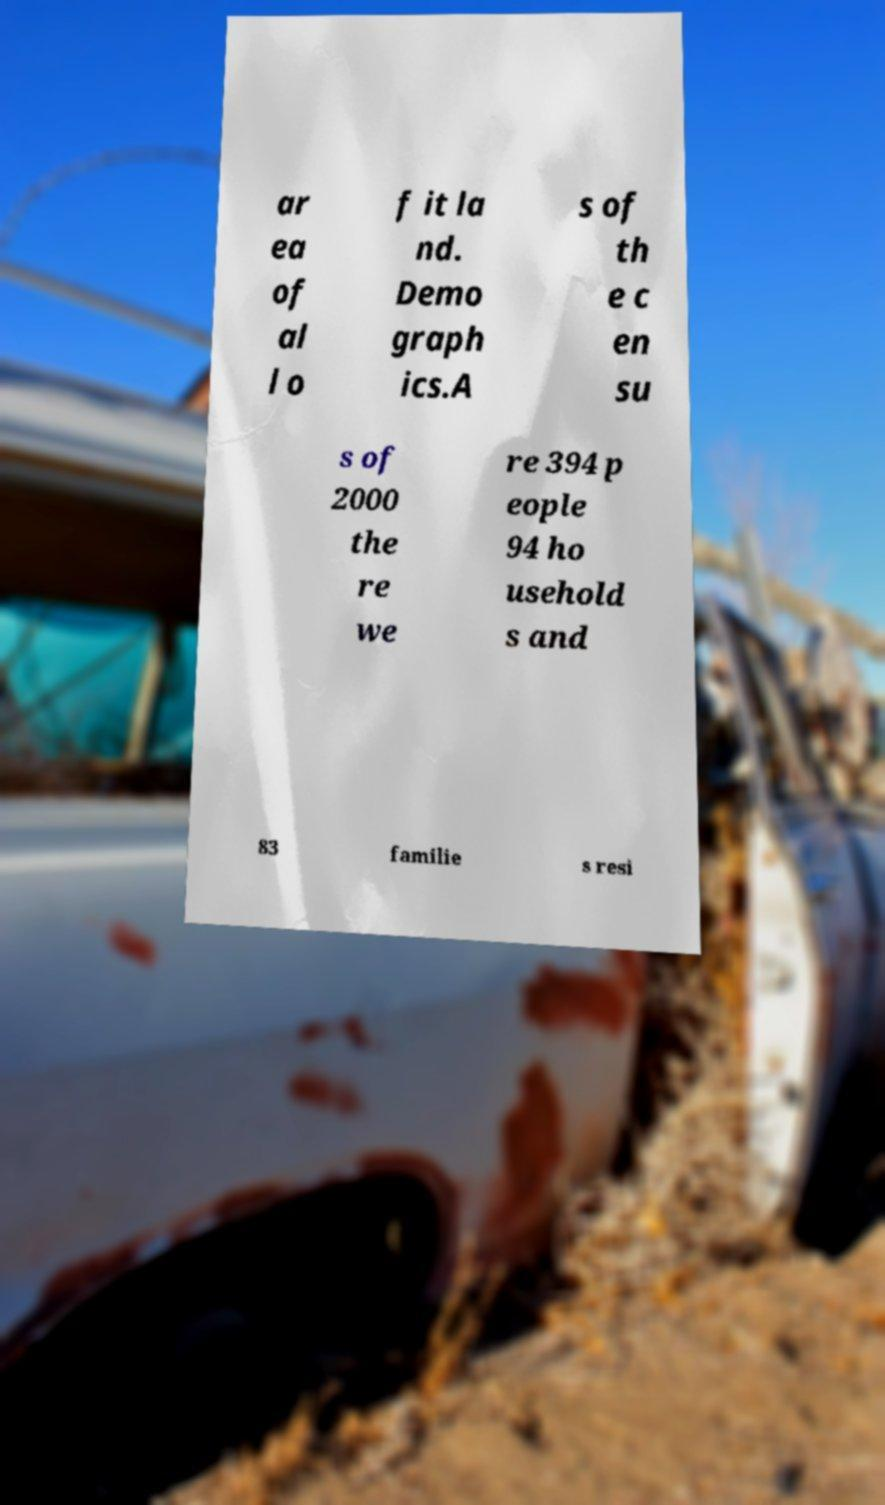Could you assist in decoding the text presented in this image and type it out clearly? ar ea of al l o f it la nd. Demo graph ics.A s of th e c en su s of 2000 the re we re 394 p eople 94 ho usehold s and 83 familie s resi 